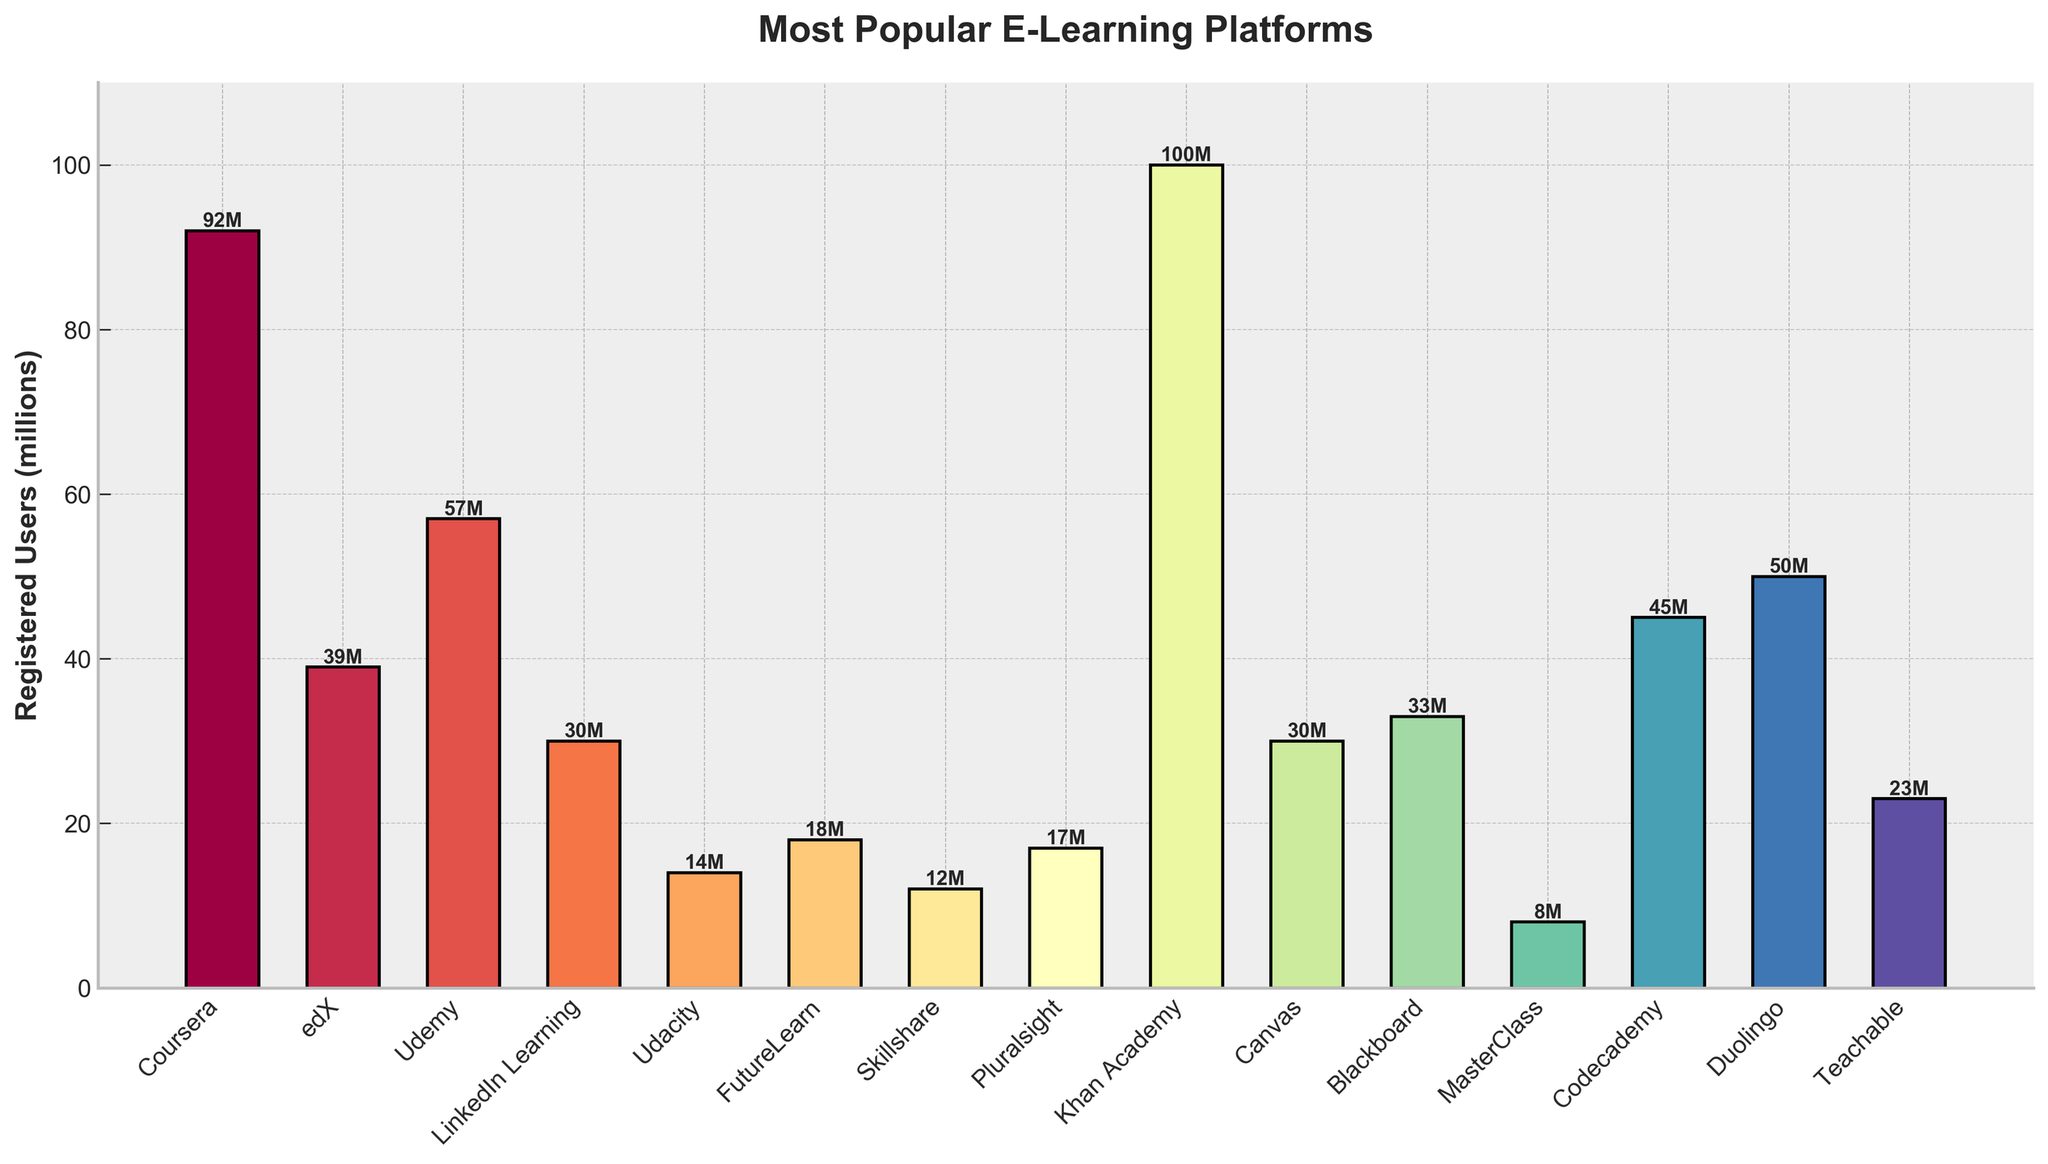Which e-learning platform has the highest number of registered users? The platform with the tallest bar represents the highest number of registered users. In the figure, Khan Academy has the tallest bar.
Answer: Khan Academy How many more registered users does Coursera have compared to edX? To find the difference, look at the heights of the bars for Coursera and edX. Coursera has 92 million, and edX has 39 million. Subtract the smaller from the larger: 92 - 39.
Answer: 53 million Which two platforms have the same number of registered users? Look for bars of equal height. Canvas and LinkedIn Learning both have bars reaching 30 million users.
Answer: Canvas and LinkedIn Learning What's the total number of registered users for the platforms with less than 20 million users? Identify platforms with less than 20 million users (Udacity, FutureLearn, Skillshare, Pluralsight, MasterClass). Add their users up: 14 + 18 + 12 + 17 + 8.
Answer: 69 million Which platform has slightly fewer registered users than Udemy? Look for the bar just slightly shorter than the bar for Udemy. Udemy has 57 million, and the next shortest bar is for Codecademy with 45 million users.
Answer: Codecademy Compare the number of registered users between Khan Academy and Duolingo. How many more users does one have over the other? Khan Academy has 100 million users, and Duolingo has 50 million. Subtract the smaller from the larger: 100 - 50.
Answer: 50 million What's the average number of registered users across all platforms? Sum the number of registered users for all platforms and divide by the number of platforms. (92 + 39 + 57 + 30 + 14 + 18 + 12 + 17 + 100 + 30 + 33 + 8 + 45 + 50 + 23) / 15.
Answer: 38.73 million Which e-learning platform has the least number of registered users? The platform with the shortest bar represents the least number of registered users. In the figure, MasterClass has the shortest bar.
Answer: MasterClass 